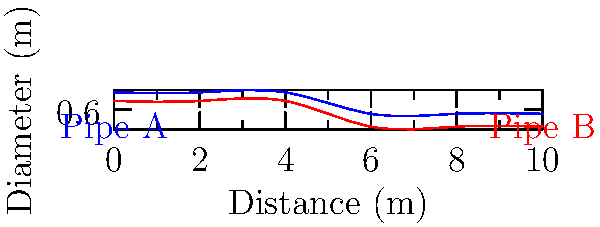In an eco-friendly water filtration system, two pipes with varying diameters are used to transport water. Given the pipe diameter profiles shown in the graph, calculate the ratio of the average flow velocity in Pipe B to Pipe A, assuming the same volumetric flow rate in both pipes. Consider the principle of conservation of mass in fluid dynamics. To solve this problem, we'll follow these steps:

1) First, recall the continuity equation for incompressible flow:
   $$ Q = A_1v_1 = A_2v_2 $$
   where Q is the volumetric flow rate, A is the cross-sectional area, and v is the velocity.

2) The average diameter for each pipe:
   Pipe A: $D_A = (1 + 0.5) / 2 = 0.75$ m
   Pipe B: $D_B = (0.8 + 0.2) / 2 = 0.5$ m

3) Calculate the average cross-sectional areas:
   $A_A = \pi (D_A/2)^2 = \pi (0.75/2)^2 = 0.44$ m²
   $A_B = \pi (D_B/2)^2 = \pi (0.5/2)^2 = 0.20$ m²

4) Using the continuity equation and assuming the same flow rate Q:
   $Q = A_Av_A = A_Bv_B$

5) Rearranging to find the velocity ratio:
   $v_B/v_A = A_A/A_B = 0.44/0.20 = 2.2$

Thus, the average flow velocity in Pipe B is 2.2 times that in Pipe A.

This design demonstrates how varying pipe diameters can be used to control flow velocities in water filtration systems, potentially improving filtration efficiency while conserving energy.
Answer: 2.2 